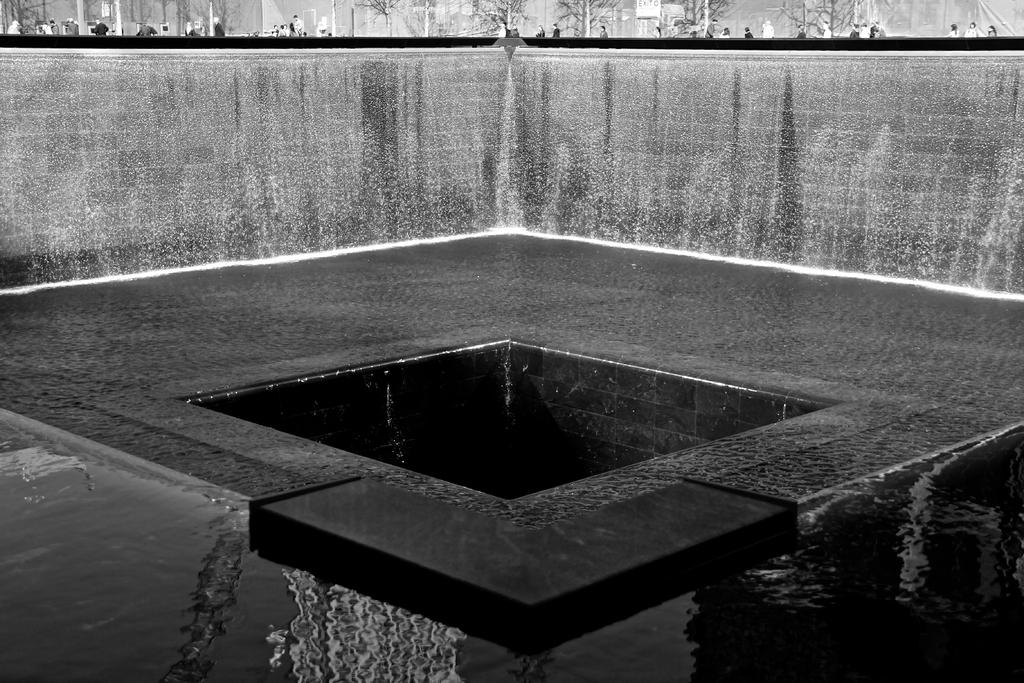What is the color scheme of the image? The image is black and white. What is the main feature in the image? There is a fountain in the image. What else can be seen in the image besides the fountain? There is a wall, trees, people, water, and the ground visible in the image. What type of base is supporting the fountain in the image? There is no base visible in the image, as it is a black and white photograph. The fountain's support structure is not discernible. 